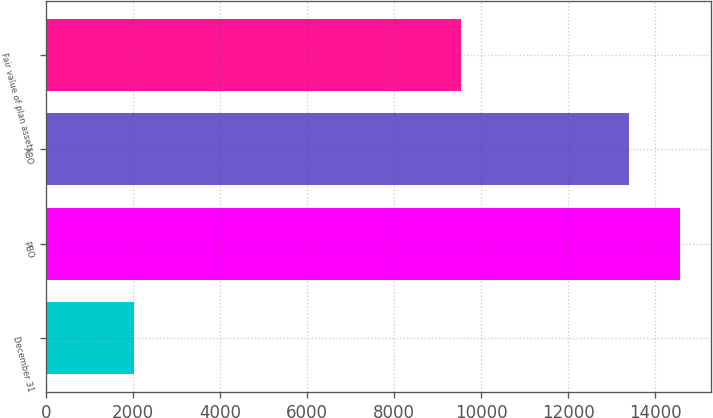Convert chart. <chart><loc_0><loc_0><loc_500><loc_500><bar_chart><fcel>December 31<fcel>PBO<fcel>ABO<fcel>Fair value of plan assets<nl><fcel>2017<fcel>14562.3<fcel>13398<fcel>9526<nl></chart> 